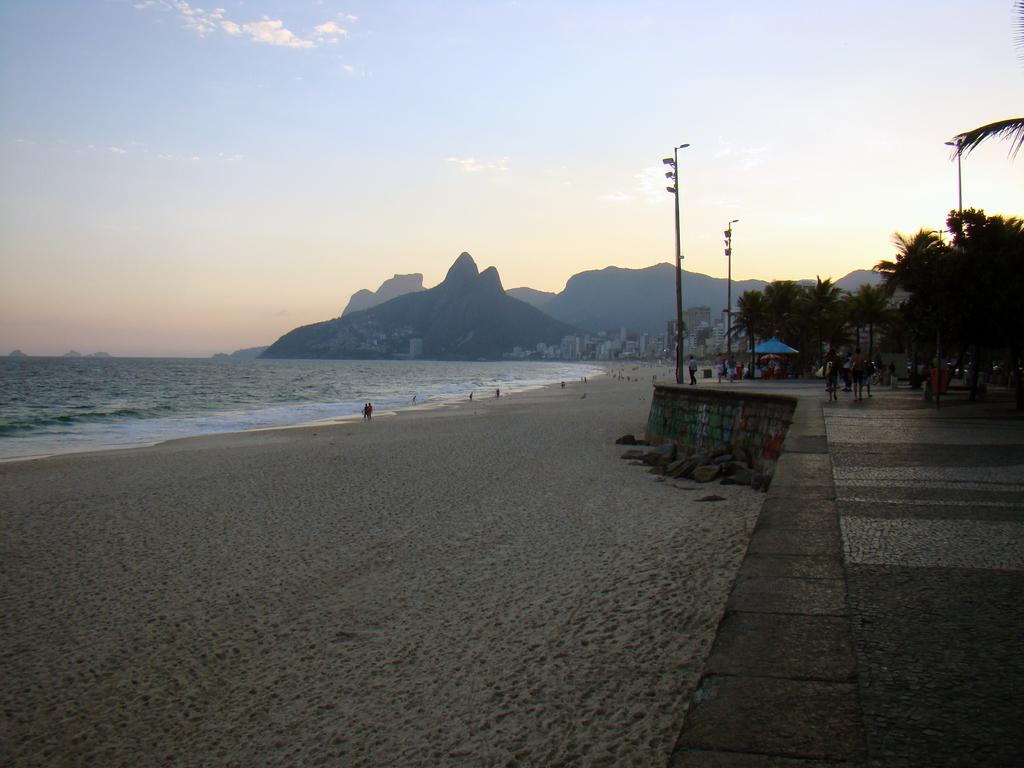What type of natural formation can be seen in the image? There are mountains in the image. What type of vegetation is present in the image? There are trees in the image. What man-made structures can be seen in the image? There are poles, a shed, buildings, and a platform visible in the image. Are there any people in the image? Yes, there are people in the image. What type of terrain is visible at the bottom of the image? There is sand at the bottom of the image. What is visible at the top of the image? The sky is visible at the top of the image. What type of water body is present in the image? There is water visible in the image. Can you tell me how many ants are crawling on the poles in the image? There are no ants present in the image. What type of screw is used to hold the shed together in the image? There is no screw visible in the image, and the shed's construction is not described. What type of plant is growing near the water in the image? There is no specific plant mentioned in the image, only trees in general. 